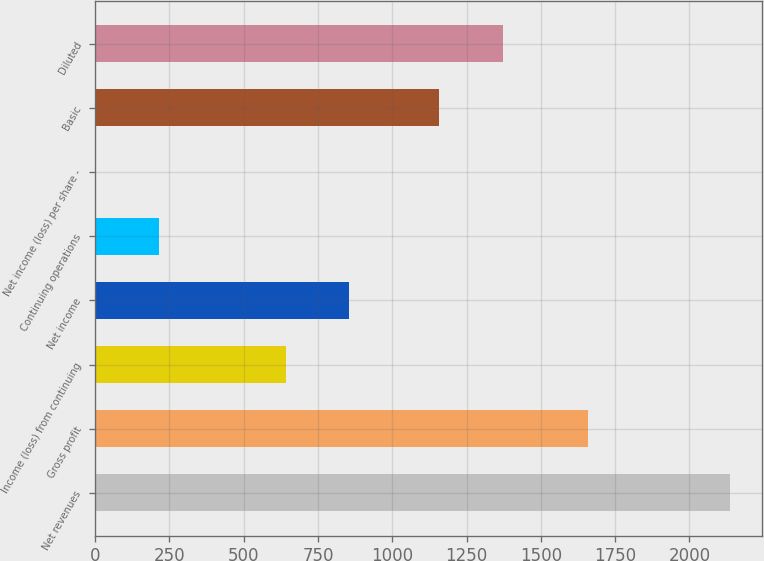<chart> <loc_0><loc_0><loc_500><loc_500><bar_chart><fcel>Net revenues<fcel>Gross profit<fcel>Income (loss) from continuing<fcel>Net income<fcel>Continuing operations<fcel>Net income (loss) per share -<fcel>Basic<fcel>Diluted<nl><fcel>2137<fcel>1660<fcel>641.39<fcel>855.05<fcel>214.07<fcel>0.41<fcel>1159<fcel>1372.66<nl></chart> 